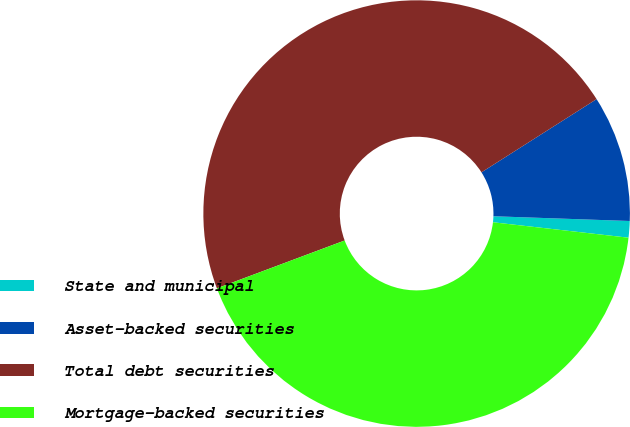<chart> <loc_0><loc_0><loc_500><loc_500><pie_chart><fcel>State and municipal<fcel>Asset-backed securities<fcel>Total debt securities<fcel>Mortgage-backed securities<nl><fcel>1.25%<fcel>9.57%<fcel>46.68%<fcel>42.49%<nl></chart> 